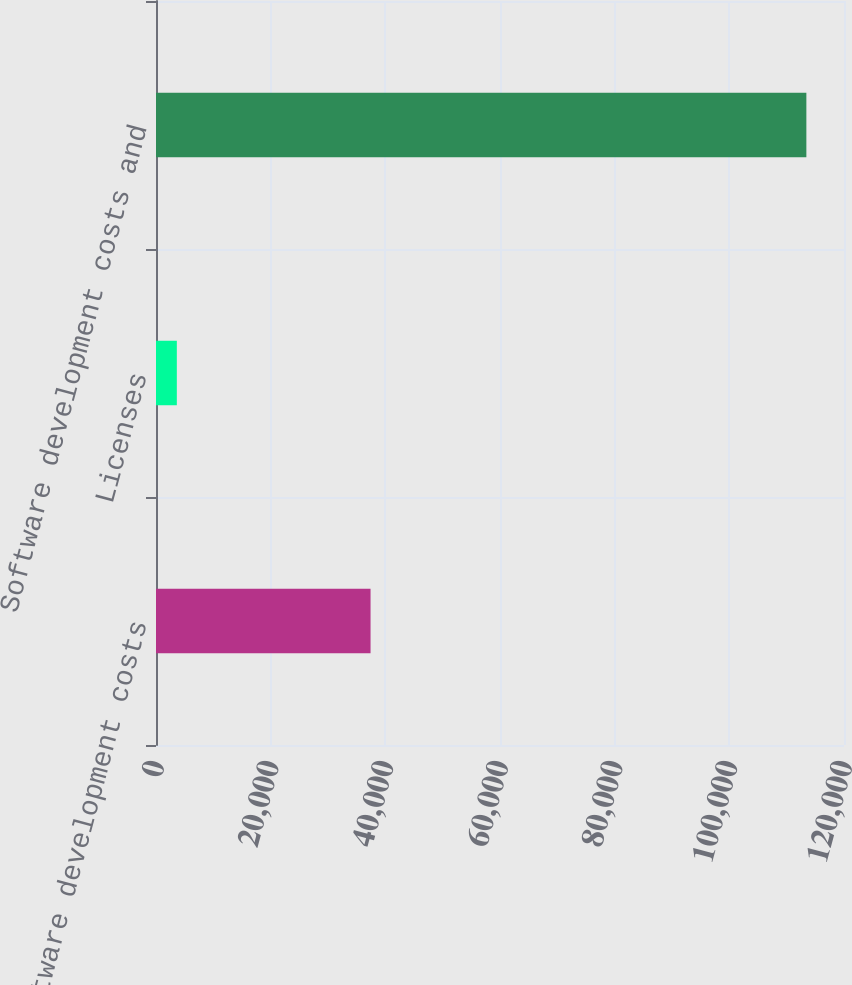Convert chart. <chart><loc_0><loc_0><loc_500><loc_500><bar_chart><fcel>Software development costs<fcel>Licenses<fcel>Software development costs and<nl><fcel>37422<fcel>3633<fcel>113436<nl></chart> 